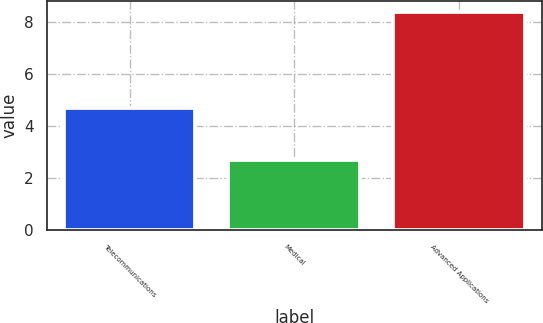Convert chart. <chart><loc_0><loc_0><loc_500><loc_500><bar_chart><fcel>Telecommunications<fcel>Medical<fcel>Advanced Applications<nl><fcel>4.7<fcel>2.7<fcel>8.4<nl></chart> 